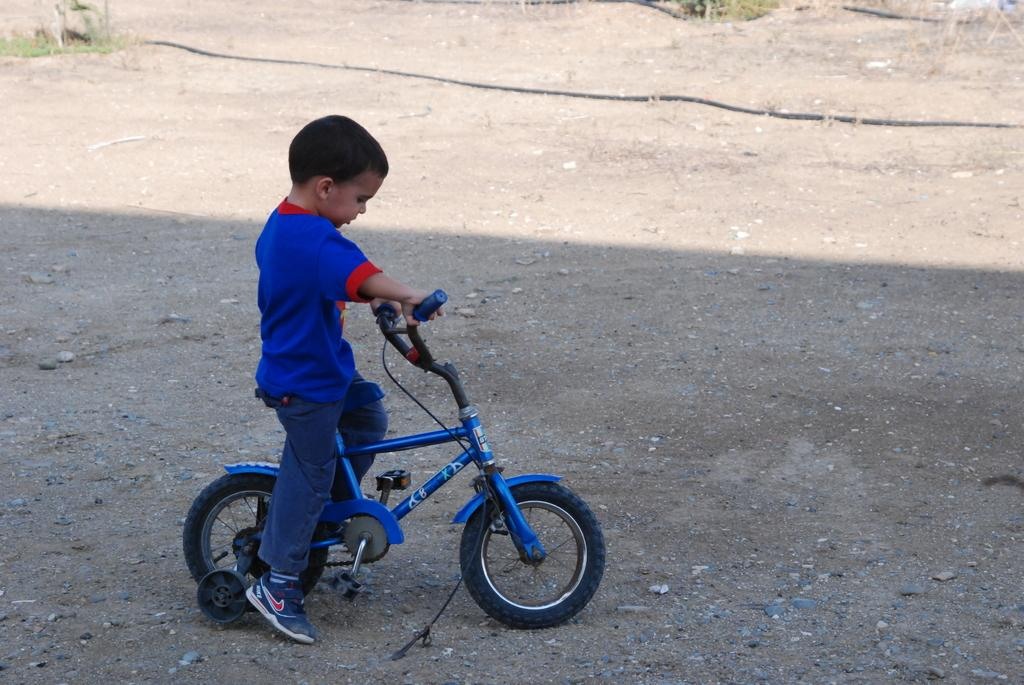Where was the picture taken? The picture was clicked outside a room. What is the boy in the image doing? The boy is riding a bicycle in the image. What is the boy wearing? The boy is wearing a blue t-shirt and blue jeans. What can be seen in the background of the image? There is sky visible in the image. What is located at the bottom of the picture? There is a pipe at the bottom of the picture. What type of vegetation is present beside the pipe? Grass is present beside the pipe. What type of behavior is the grandmother exhibiting in the image? There is no grandmother present in the image, so it is not possible to answer that question. 